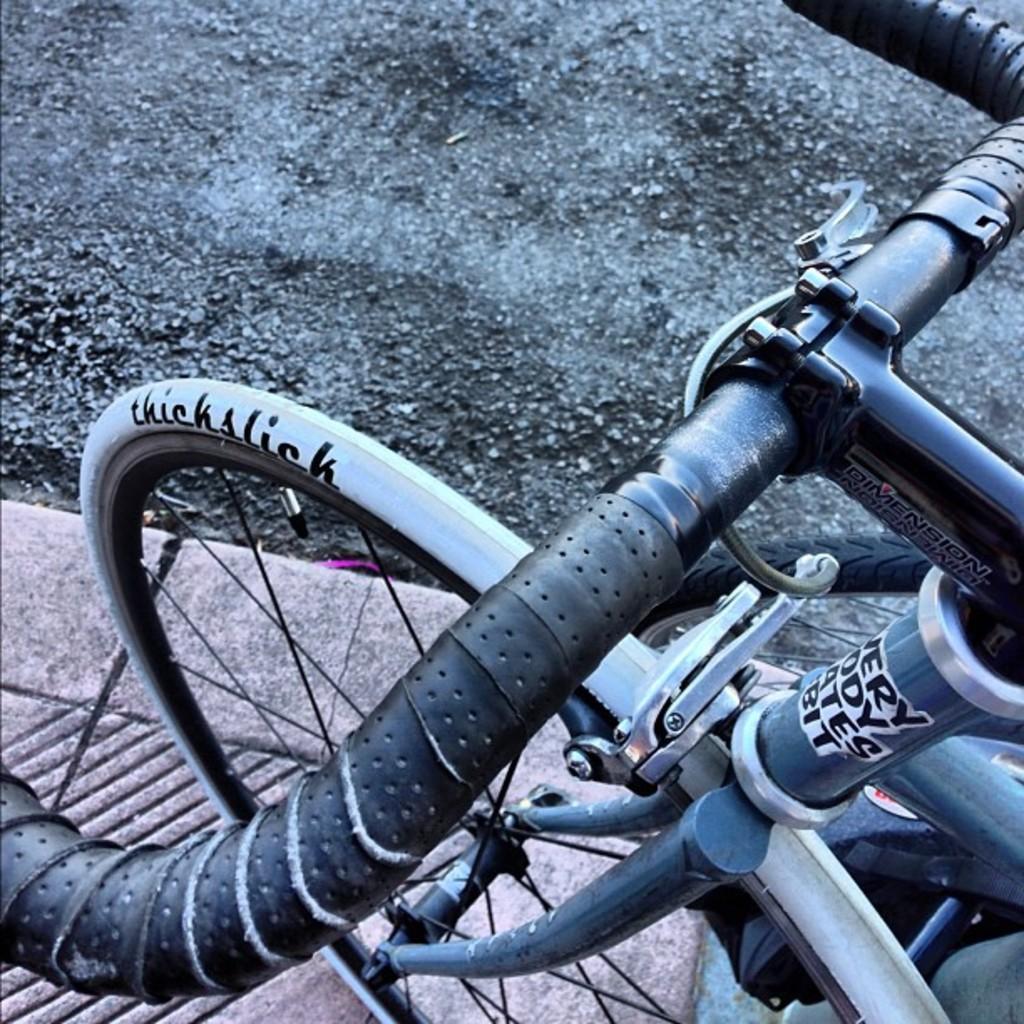How would you summarize this image in a sentence or two? In the foreground of the picture we can see a bicycle. At the bottom it is footpath. At the top there is road. 